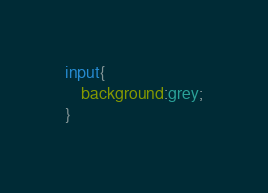<code> <loc_0><loc_0><loc_500><loc_500><_CSS_>input{
	background:grey;
}</code> 